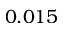<formula> <loc_0><loc_0><loc_500><loc_500>0 . 0 1 5</formula> 